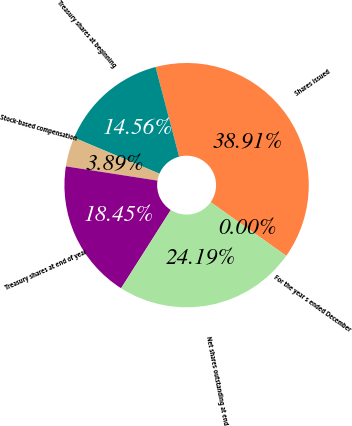Convert chart to OTSL. <chart><loc_0><loc_0><loc_500><loc_500><pie_chart><fcel>For the year s ended December<fcel>Shares issued<fcel>Treasury shares at beginning<fcel>Stock-based compensation<fcel>Treasury shares at end of year<fcel>Net shares outstanding at end<nl><fcel>0.0%<fcel>38.91%<fcel>14.56%<fcel>3.89%<fcel>18.45%<fcel>24.19%<nl></chart> 